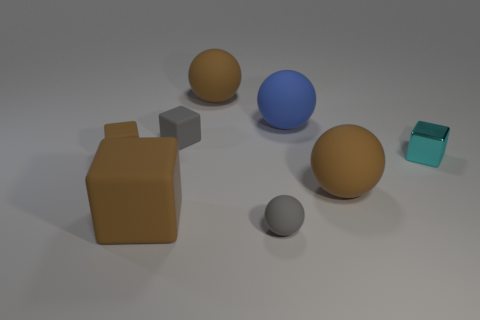There is a large matte block; is its color the same as the big rubber ball that is in front of the metallic thing?
Give a very brief answer. Yes. There is another block that is the same color as the large rubber block; what material is it?
Keep it short and to the point. Rubber. How many metal cubes are in front of the big block?
Provide a succinct answer. 0. There is a big brown sphere behind the big matte ball in front of the big blue thing; what is it made of?
Keep it short and to the point. Rubber. There is a ball that is the same size as the gray rubber cube; what is its material?
Make the answer very short. Rubber. Is there a shiny block of the same size as the blue thing?
Your response must be concise. No. There is a metallic thing that is on the right side of the small brown rubber cube; what color is it?
Provide a succinct answer. Cyan. Is there a large brown matte object that is right of the big brown ball that is to the right of the blue rubber object?
Ensure brevity in your answer.  No. How many other things are there of the same color as the tiny matte ball?
Make the answer very short. 1. Is the size of the gray rubber thing in front of the small metallic cube the same as the brown matte sphere in front of the small cyan object?
Keep it short and to the point. No. 